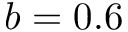<formula> <loc_0><loc_0><loc_500><loc_500>b = 0 . 6</formula> 